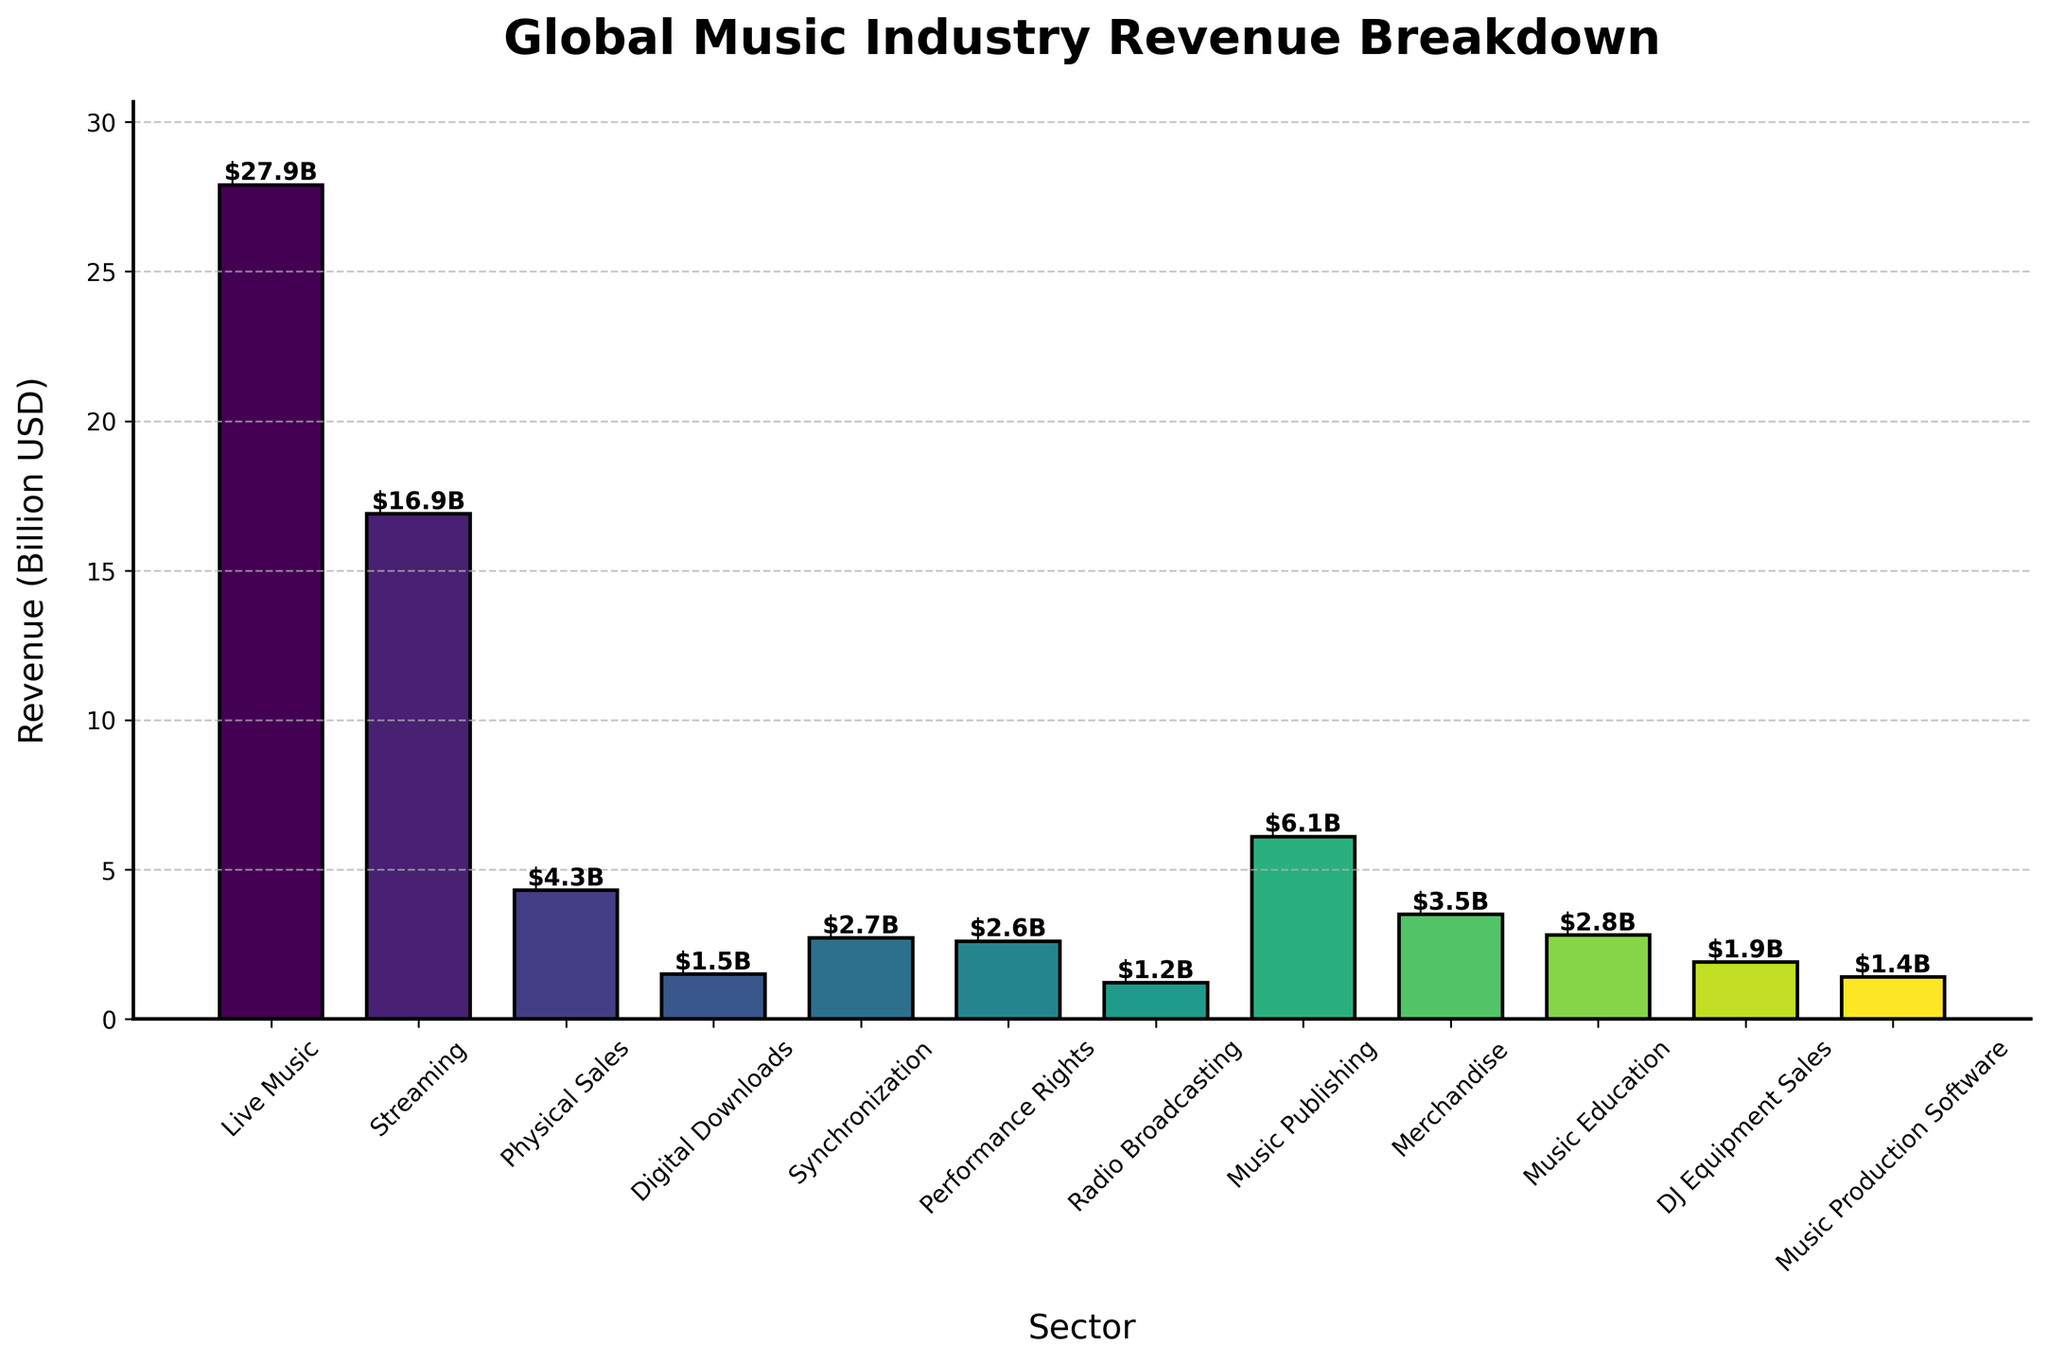What is the combined revenue of Physical Sales and Music Publishing? Add the heights of the bars labeled "Physical Sales" and "Music Publishing." Phyiscal Sales generate $4.3B and Music Publishing generates $6.1B. The combined revenue is $4.3B + $6.1B = $10.4B.
Answer: $10.4B What is the total revenue generated by Digital Downloads, Synchronization, and Radio Broadcasting combined? Add the heights of the bars labeled "Digital Downloads," "Synchronization," and "Radio Broadcasting." Digital Downloads generate $1.5B, Synchronization generates $2.7B, and Radio Broadcasting generates $1.2B. The total revenue is $1.5B + $2.7B + $1.2B = $5.4B.
Answer: $5.4B Is the revenue from Performance Rights higher than Radio Broadcasting? Compare the heights of the bars labeled "Performance Rights" and "Radio Broadcasting." The bar for Performance Rights is taller, indicating its revenue is higher.
Answer: Yes What percentage of the total revenue is generated by Streaming? Sum the revenue of all sectors to find the total revenue, then divide the revenue of Streaming by the total and multiply by 100 to find the percentage. Total revenue = $71.9B, Streaming revenue = $16.9B. Percentage = ($16.9B / $71.9B) * 100 ≈ 23.5%.
Answer: 23.5% Put the top three revenue-generating sectors in order. Identify the three tallest bars. They are "Live Music," "Streaming," and "Music Publishing." Order by height from tallest to shortest: Live Music, Streaming, Music Publishing.
Answer: Live Music, Streaming, Music Publishing 